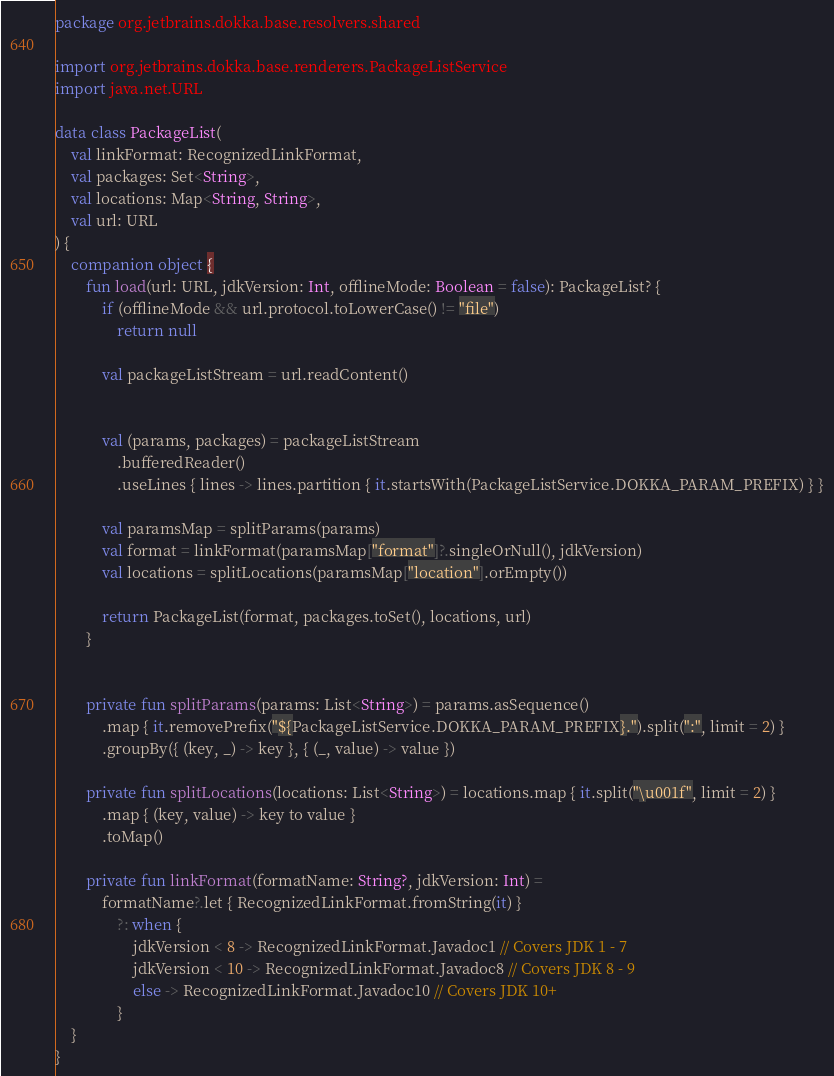<code> <loc_0><loc_0><loc_500><loc_500><_Kotlin_>package org.jetbrains.dokka.base.resolvers.shared

import org.jetbrains.dokka.base.renderers.PackageListService
import java.net.URL

data class PackageList(
    val linkFormat: RecognizedLinkFormat,
    val packages: Set<String>,
    val locations: Map<String, String>,
    val url: URL
) {
    companion object {
        fun load(url: URL, jdkVersion: Int, offlineMode: Boolean = false): PackageList? {
            if (offlineMode && url.protocol.toLowerCase() != "file")
                return null

            val packageListStream = url.readContent()


            val (params, packages) = packageListStream
                .bufferedReader()
                .useLines { lines -> lines.partition { it.startsWith(PackageListService.DOKKA_PARAM_PREFIX) } }

            val paramsMap = splitParams(params)
            val format = linkFormat(paramsMap["format"]?.singleOrNull(), jdkVersion)
            val locations = splitLocations(paramsMap["location"].orEmpty())

            return PackageList(format, packages.toSet(), locations, url)
        }


        private fun splitParams(params: List<String>) = params.asSequence()
            .map { it.removePrefix("${PackageListService.DOKKA_PARAM_PREFIX}.").split(":", limit = 2) }
            .groupBy({ (key, _) -> key }, { (_, value) -> value })

        private fun splitLocations(locations: List<String>) = locations.map { it.split("\u001f", limit = 2) }
            .map { (key, value) -> key to value }
            .toMap()

        private fun linkFormat(formatName: String?, jdkVersion: Int) =
            formatName?.let { RecognizedLinkFormat.fromString(it) }
                ?: when {
                    jdkVersion < 8 -> RecognizedLinkFormat.Javadoc1 // Covers JDK 1 - 7
                    jdkVersion < 10 -> RecognizedLinkFormat.Javadoc8 // Covers JDK 8 - 9
                    else -> RecognizedLinkFormat.Javadoc10 // Covers JDK 10+
                }
    }
}
</code> 